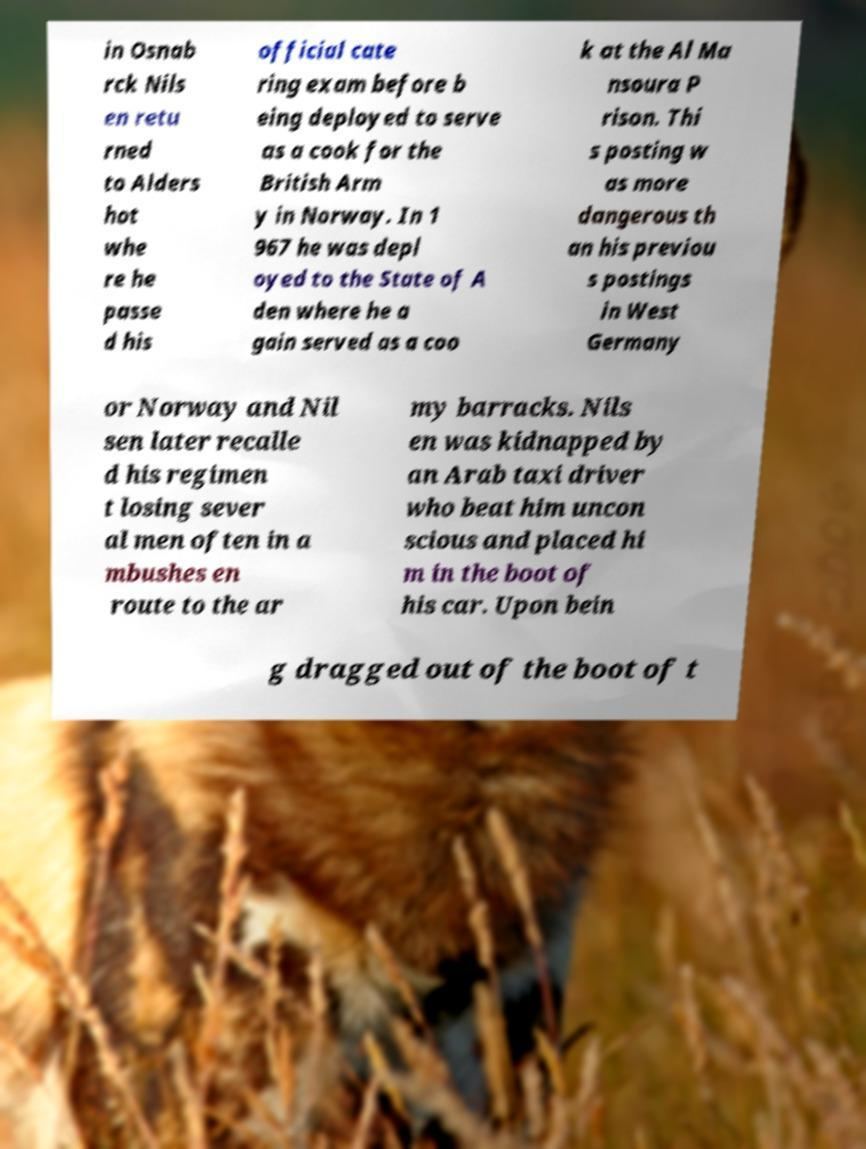Please read and relay the text visible in this image. What does it say? in Osnab rck Nils en retu rned to Alders hot whe re he passe d his official cate ring exam before b eing deployed to serve as a cook for the British Arm y in Norway. In 1 967 he was depl oyed to the State of A den where he a gain served as a coo k at the Al Ma nsoura P rison. Thi s posting w as more dangerous th an his previou s postings in West Germany or Norway and Nil sen later recalle d his regimen t losing sever al men often in a mbushes en route to the ar my barracks. Nils en was kidnapped by an Arab taxi driver who beat him uncon scious and placed hi m in the boot of his car. Upon bein g dragged out of the boot of t 